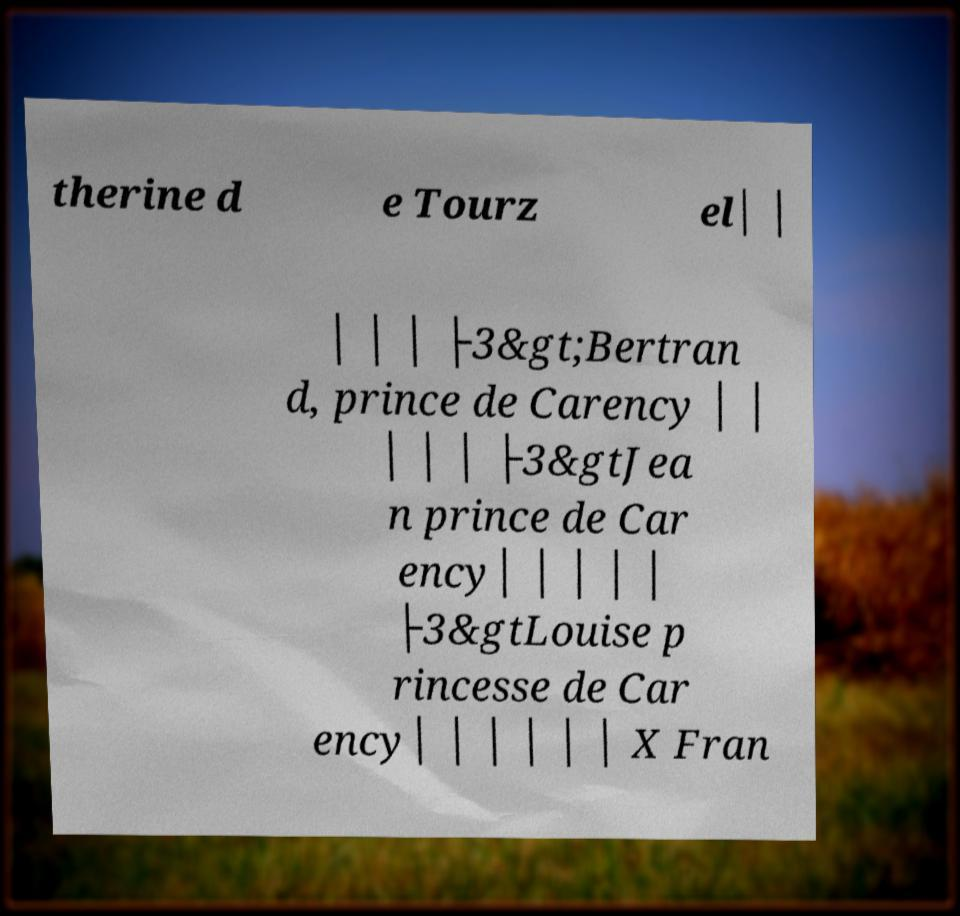Please identify and transcribe the text found in this image. therine d e Tourz el│ │ │ │ │ ├3&gt;Bertran d, prince de Carency │ │ │ │ │ ├3&gtJea n prince de Car ency│ │ │ │ │ ├3&gtLouise p rincesse de Car ency│ │ │ │ │ │ X Fran 